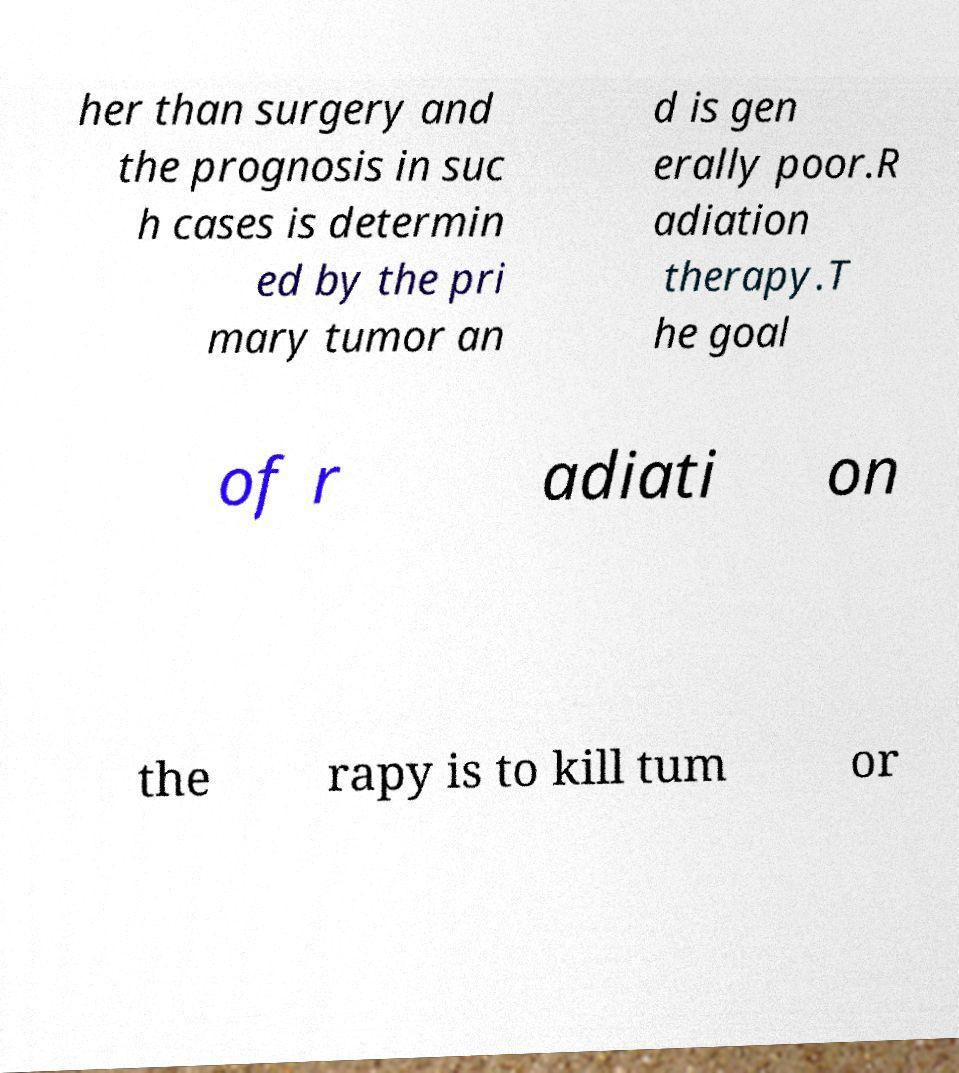Can you read and provide the text displayed in the image?This photo seems to have some interesting text. Can you extract and type it out for me? her than surgery and the prognosis in suc h cases is determin ed by the pri mary tumor an d is gen erally poor.R adiation therapy.T he goal of r adiati on the rapy is to kill tum or 